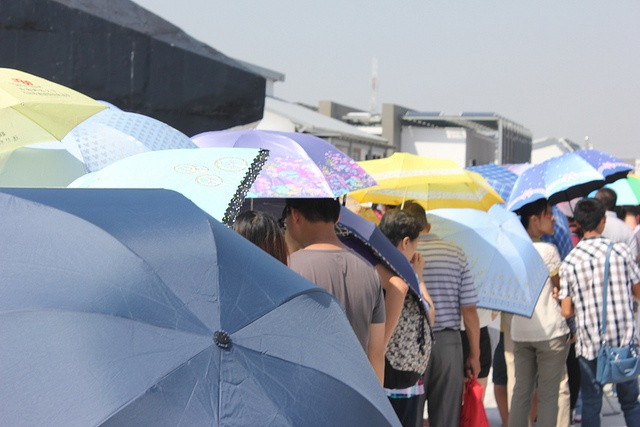Describe the objects in this image and their specific colors. I can see umbrella in black, gray, and darkgray tones, people in black, lightgray, darkgray, and gray tones, people in black, gray, darkgray, and brown tones, people in black, gray, and darkgray tones, and people in black, gray, darkgray, and lightgray tones in this image. 